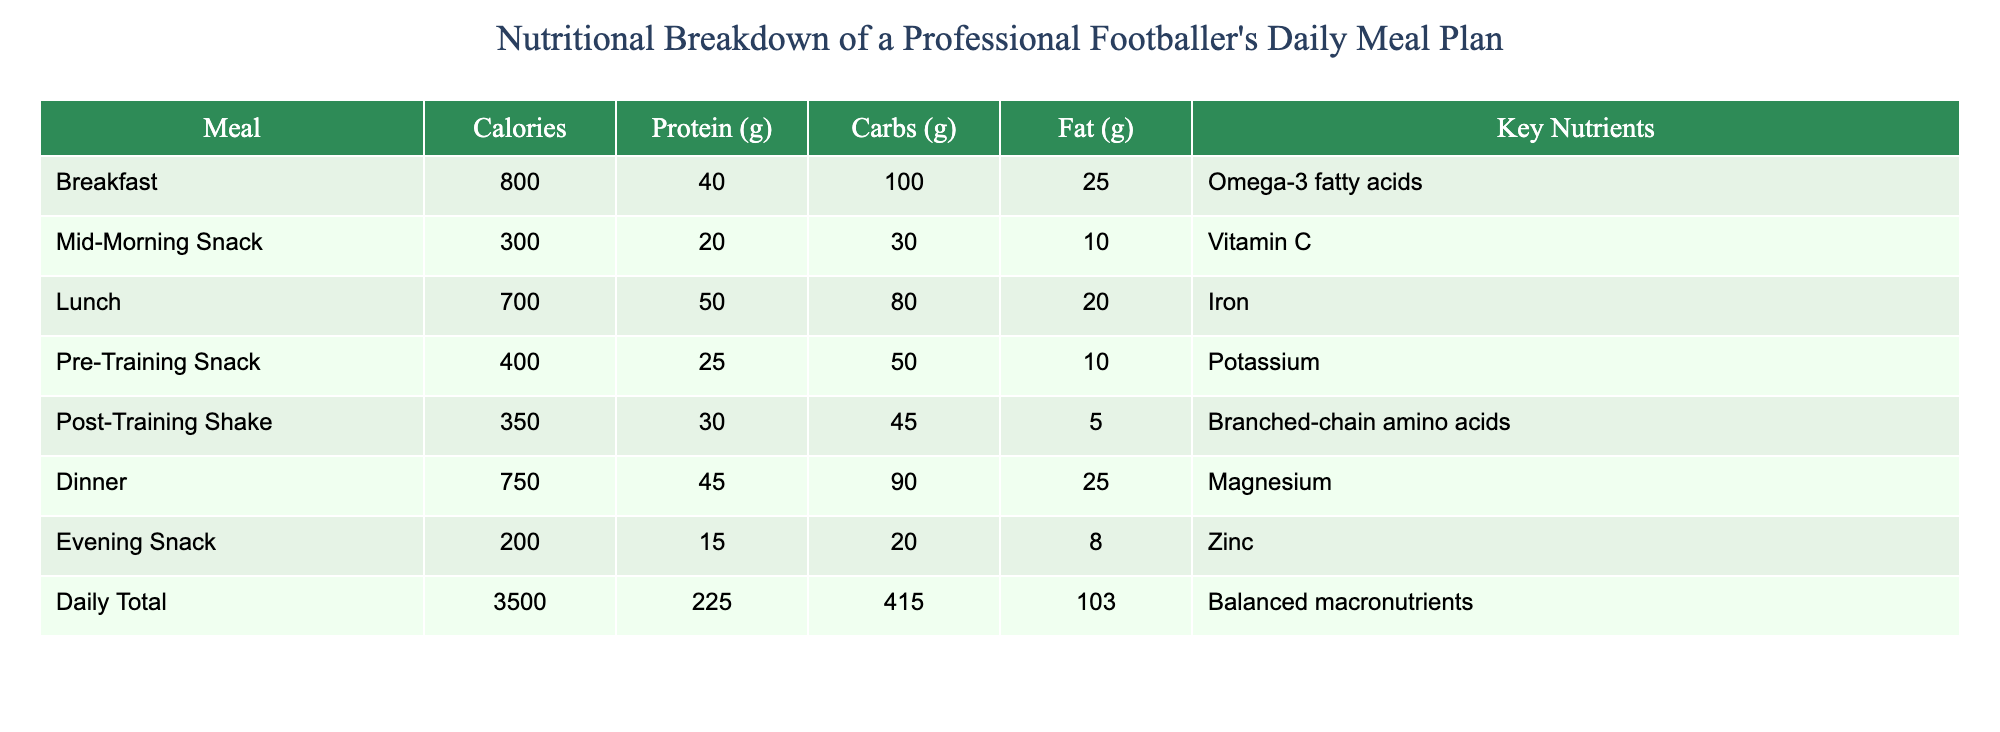What is the total calorie intake for the day? The daily total calories is presented at the bottom of the table, which states "Daily Total" followed by the value 3500.
Answer: 3500 Which meal has the highest protein content? Scanning through the table, we find that Lunch has 50 grams of protein, which is the highest when compared to the values of other meals.
Answer: Lunch How many grams of carbohydrates does the Pre-Training Snack provide? Looking at the "Pre-Training Snack" row, we can see that it specifies 50 grams of carbohydrates.
Answer: 50 grams Is the total fat intake for the day over or under 100 grams? The daily total for fat is provided as 103 grams. Since this number is over 100 grams, the answer is yes.
Answer: Yes What is the average protein intake per meal? To find the average protein intake, sum the protein values: 40 + 20 + 50 + 25 + 30 + 45 + 15 = 225 grams. There are 7 meals, so 225 grams divided by 7 gives approximately 32.14 grams per meal.
Answer: Approximately 32.14 grams Which meal provides the least amount of calories? By inspecting the "Calories" column, the Evening Snack has the least calories listed at 200.
Answer: Evening Snack What is the difference in calories between Breakfast and Dinner? The Breakfast has 800 calories, and Dinner has 750 calories. The difference is 800 - 750 = 50 calories.
Answer: 50 calories Does the Lunch contain more carbohydrates than the Mid-Morning Snack? Lunch has 80 grams of carbohydrates and the Mid-Morning Snack has 30 grams. Since 80 grams is greater than 30 grams, the answer is yes.
Answer: Yes What nutrient is associated with the highest calorie meal? The Breakfast meal has the highest calorie count at 800 calories, and it is associated with Omega-3 fatty acids as the key nutrient.
Answer: Omega-3 fatty acids 